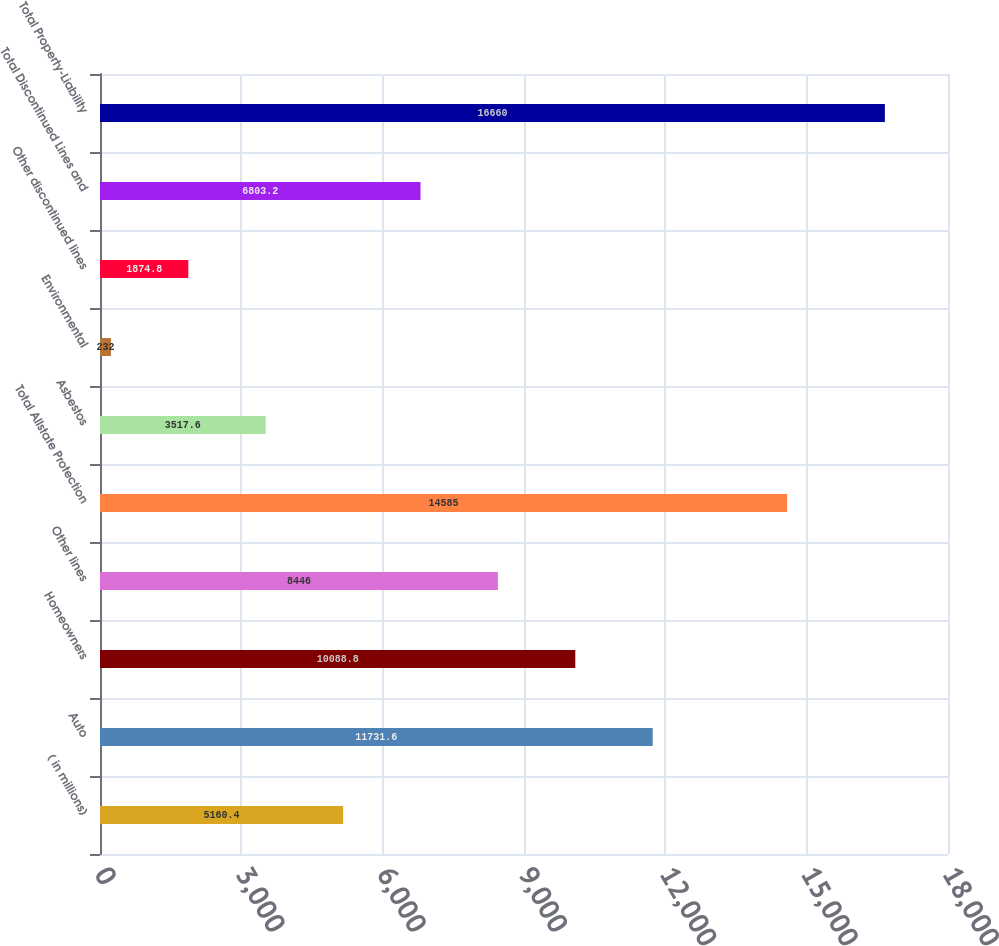Convert chart. <chart><loc_0><loc_0><loc_500><loc_500><bar_chart><fcel>( in millions)<fcel>Auto<fcel>Homeowners<fcel>Other lines<fcel>Total Allstate Protection<fcel>Asbestos<fcel>Environmental<fcel>Other discontinued lines<fcel>Total Discontinued Lines and<fcel>Total Property-Liability<nl><fcel>5160.4<fcel>11731.6<fcel>10088.8<fcel>8446<fcel>14585<fcel>3517.6<fcel>232<fcel>1874.8<fcel>6803.2<fcel>16660<nl></chart> 